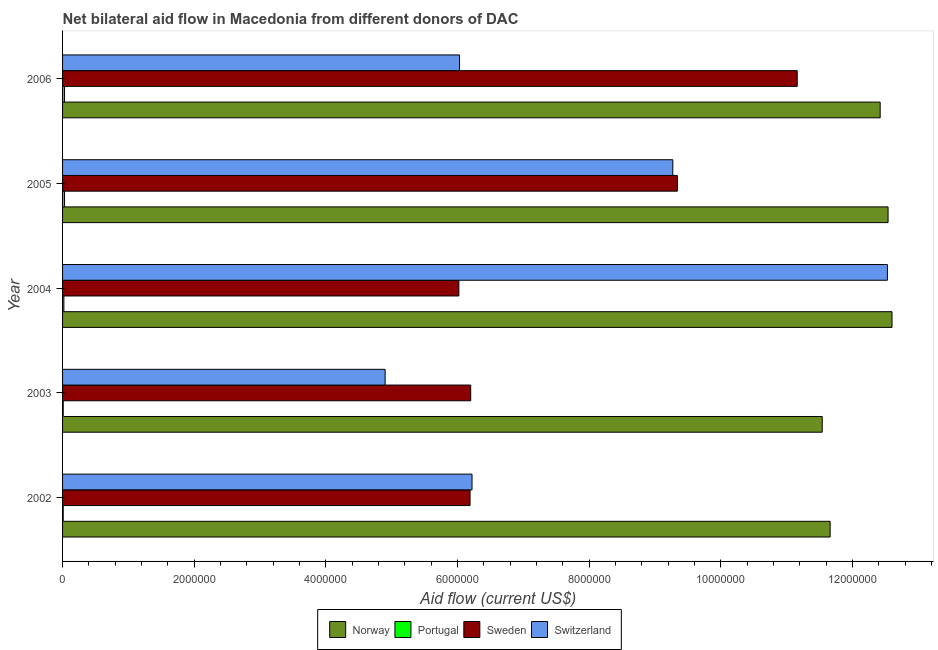How many different coloured bars are there?
Your answer should be compact. 4. Are the number of bars per tick equal to the number of legend labels?
Provide a short and direct response. Yes. Are the number of bars on each tick of the Y-axis equal?
Your answer should be very brief. Yes. How many bars are there on the 5th tick from the top?
Your answer should be very brief. 4. What is the label of the 3rd group of bars from the top?
Offer a very short reply. 2004. In how many cases, is the number of bars for a given year not equal to the number of legend labels?
Provide a short and direct response. 0. What is the amount of aid given by portugal in 2004?
Your answer should be compact. 2.00e+04. Across all years, what is the maximum amount of aid given by portugal?
Provide a short and direct response. 3.00e+04. Across all years, what is the minimum amount of aid given by sweden?
Your response must be concise. 6.02e+06. In which year was the amount of aid given by switzerland maximum?
Your answer should be compact. 2004. In which year was the amount of aid given by norway minimum?
Your answer should be very brief. 2003. What is the total amount of aid given by norway in the graph?
Your answer should be very brief. 6.08e+07. What is the difference between the amount of aid given by switzerland in 2003 and that in 2004?
Keep it short and to the point. -7.63e+06. What is the difference between the amount of aid given by norway in 2002 and the amount of aid given by portugal in 2005?
Offer a very short reply. 1.16e+07. What is the average amount of aid given by portugal per year?
Give a very brief answer. 2.00e+04. In the year 2006, what is the difference between the amount of aid given by portugal and amount of aid given by sweden?
Make the answer very short. -1.11e+07. What is the ratio of the amount of aid given by norway in 2002 to that in 2003?
Provide a succinct answer. 1.01. Is the amount of aid given by norway in 2004 less than that in 2006?
Offer a very short reply. No. Is the difference between the amount of aid given by switzerland in 2004 and 2006 greater than the difference between the amount of aid given by norway in 2004 and 2006?
Your answer should be compact. Yes. What is the difference between the highest and the lowest amount of aid given by switzerland?
Provide a short and direct response. 7.63e+06. In how many years, is the amount of aid given by sweden greater than the average amount of aid given by sweden taken over all years?
Your answer should be compact. 2. Is the sum of the amount of aid given by switzerland in 2002 and 2003 greater than the maximum amount of aid given by norway across all years?
Your answer should be compact. No. Is it the case that in every year, the sum of the amount of aid given by portugal and amount of aid given by sweden is greater than the sum of amount of aid given by switzerland and amount of aid given by norway?
Your answer should be compact. No. What does the 4th bar from the bottom in 2006 represents?
Your answer should be very brief. Switzerland. Is it the case that in every year, the sum of the amount of aid given by norway and amount of aid given by portugal is greater than the amount of aid given by sweden?
Your answer should be very brief. Yes. How many bars are there?
Provide a short and direct response. 20. Are all the bars in the graph horizontal?
Your answer should be very brief. Yes. Does the graph contain grids?
Ensure brevity in your answer.  No. How many legend labels are there?
Your answer should be compact. 4. How are the legend labels stacked?
Your answer should be very brief. Horizontal. What is the title of the graph?
Offer a terse response. Net bilateral aid flow in Macedonia from different donors of DAC. Does "Debt policy" appear as one of the legend labels in the graph?
Offer a very short reply. No. What is the label or title of the X-axis?
Your answer should be compact. Aid flow (current US$). What is the label or title of the Y-axis?
Offer a very short reply. Year. What is the Aid flow (current US$) of Norway in 2002?
Offer a very short reply. 1.17e+07. What is the Aid flow (current US$) in Portugal in 2002?
Your response must be concise. 10000. What is the Aid flow (current US$) in Sweden in 2002?
Your answer should be compact. 6.19e+06. What is the Aid flow (current US$) of Switzerland in 2002?
Offer a terse response. 6.22e+06. What is the Aid flow (current US$) of Norway in 2003?
Provide a short and direct response. 1.15e+07. What is the Aid flow (current US$) in Sweden in 2003?
Give a very brief answer. 6.20e+06. What is the Aid flow (current US$) in Switzerland in 2003?
Your response must be concise. 4.90e+06. What is the Aid flow (current US$) in Norway in 2004?
Your answer should be compact. 1.26e+07. What is the Aid flow (current US$) in Sweden in 2004?
Make the answer very short. 6.02e+06. What is the Aid flow (current US$) of Switzerland in 2004?
Your response must be concise. 1.25e+07. What is the Aid flow (current US$) in Norway in 2005?
Offer a very short reply. 1.25e+07. What is the Aid flow (current US$) in Portugal in 2005?
Your response must be concise. 3.00e+04. What is the Aid flow (current US$) of Sweden in 2005?
Your answer should be very brief. 9.34e+06. What is the Aid flow (current US$) in Switzerland in 2005?
Make the answer very short. 9.27e+06. What is the Aid flow (current US$) in Norway in 2006?
Offer a terse response. 1.24e+07. What is the Aid flow (current US$) in Sweden in 2006?
Provide a succinct answer. 1.12e+07. What is the Aid flow (current US$) of Switzerland in 2006?
Keep it short and to the point. 6.03e+06. Across all years, what is the maximum Aid flow (current US$) of Norway?
Make the answer very short. 1.26e+07. Across all years, what is the maximum Aid flow (current US$) of Portugal?
Keep it short and to the point. 3.00e+04. Across all years, what is the maximum Aid flow (current US$) in Sweden?
Your answer should be compact. 1.12e+07. Across all years, what is the maximum Aid flow (current US$) in Switzerland?
Give a very brief answer. 1.25e+07. Across all years, what is the minimum Aid flow (current US$) of Norway?
Your response must be concise. 1.15e+07. Across all years, what is the minimum Aid flow (current US$) in Portugal?
Keep it short and to the point. 10000. Across all years, what is the minimum Aid flow (current US$) of Sweden?
Your answer should be compact. 6.02e+06. Across all years, what is the minimum Aid flow (current US$) of Switzerland?
Provide a short and direct response. 4.90e+06. What is the total Aid flow (current US$) in Norway in the graph?
Make the answer very short. 6.08e+07. What is the total Aid flow (current US$) in Portugal in the graph?
Keep it short and to the point. 1.00e+05. What is the total Aid flow (current US$) of Sweden in the graph?
Offer a very short reply. 3.89e+07. What is the total Aid flow (current US$) in Switzerland in the graph?
Your answer should be very brief. 3.90e+07. What is the difference between the Aid flow (current US$) in Norway in 2002 and that in 2003?
Your answer should be very brief. 1.20e+05. What is the difference between the Aid flow (current US$) of Portugal in 2002 and that in 2003?
Offer a very short reply. 0. What is the difference between the Aid flow (current US$) in Sweden in 2002 and that in 2003?
Your answer should be very brief. -10000. What is the difference between the Aid flow (current US$) of Switzerland in 2002 and that in 2003?
Give a very brief answer. 1.32e+06. What is the difference between the Aid flow (current US$) of Norway in 2002 and that in 2004?
Provide a short and direct response. -9.40e+05. What is the difference between the Aid flow (current US$) in Sweden in 2002 and that in 2004?
Ensure brevity in your answer.  1.70e+05. What is the difference between the Aid flow (current US$) in Switzerland in 2002 and that in 2004?
Your response must be concise. -6.31e+06. What is the difference between the Aid flow (current US$) of Norway in 2002 and that in 2005?
Provide a short and direct response. -8.80e+05. What is the difference between the Aid flow (current US$) in Portugal in 2002 and that in 2005?
Provide a succinct answer. -2.00e+04. What is the difference between the Aid flow (current US$) in Sweden in 2002 and that in 2005?
Make the answer very short. -3.15e+06. What is the difference between the Aid flow (current US$) of Switzerland in 2002 and that in 2005?
Make the answer very short. -3.05e+06. What is the difference between the Aid flow (current US$) in Norway in 2002 and that in 2006?
Ensure brevity in your answer.  -7.60e+05. What is the difference between the Aid flow (current US$) of Sweden in 2002 and that in 2006?
Give a very brief answer. -4.97e+06. What is the difference between the Aid flow (current US$) of Norway in 2003 and that in 2004?
Offer a very short reply. -1.06e+06. What is the difference between the Aid flow (current US$) in Portugal in 2003 and that in 2004?
Provide a succinct answer. -10000. What is the difference between the Aid flow (current US$) in Sweden in 2003 and that in 2004?
Offer a terse response. 1.80e+05. What is the difference between the Aid flow (current US$) of Switzerland in 2003 and that in 2004?
Keep it short and to the point. -7.63e+06. What is the difference between the Aid flow (current US$) of Sweden in 2003 and that in 2005?
Give a very brief answer. -3.14e+06. What is the difference between the Aid flow (current US$) in Switzerland in 2003 and that in 2005?
Provide a short and direct response. -4.37e+06. What is the difference between the Aid flow (current US$) in Norway in 2003 and that in 2006?
Your answer should be very brief. -8.80e+05. What is the difference between the Aid flow (current US$) of Portugal in 2003 and that in 2006?
Give a very brief answer. -2.00e+04. What is the difference between the Aid flow (current US$) of Sweden in 2003 and that in 2006?
Offer a terse response. -4.96e+06. What is the difference between the Aid flow (current US$) of Switzerland in 2003 and that in 2006?
Your answer should be very brief. -1.13e+06. What is the difference between the Aid flow (current US$) in Norway in 2004 and that in 2005?
Keep it short and to the point. 6.00e+04. What is the difference between the Aid flow (current US$) of Portugal in 2004 and that in 2005?
Make the answer very short. -10000. What is the difference between the Aid flow (current US$) of Sweden in 2004 and that in 2005?
Ensure brevity in your answer.  -3.32e+06. What is the difference between the Aid flow (current US$) of Switzerland in 2004 and that in 2005?
Your answer should be very brief. 3.26e+06. What is the difference between the Aid flow (current US$) of Norway in 2004 and that in 2006?
Keep it short and to the point. 1.80e+05. What is the difference between the Aid flow (current US$) in Sweden in 2004 and that in 2006?
Keep it short and to the point. -5.14e+06. What is the difference between the Aid flow (current US$) in Switzerland in 2004 and that in 2006?
Provide a succinct answer. 6.50e+06. What is the difference between the Aid flow (current US$) in Norway in 2005 and that in 2006?
Your answer should be very brief. 1.20e+05. What is the difference between the Aid flow (current US$) of Sweden in 2005 and that in 2006?
Your answer should be compact. -1.82e+06. What is the difference between the Aid flow (current US$) in Switzerland in 2005 and that in 2006?
Ensure brevity in your answer.  3.24e+06. What is the difference between the Aid flow (current US$) in Norway in 2002 and the Aid flow (current US$) in Portugal in 2003?
Give a very brief answer. 1.16e+07. What is the difference between the Aid flow (current US$) in Norway in 2002 and the Aid flow (current US$) in Sweden in 2003?
Provide a succinct answer. 5.46e+06. What is the difference between the Aid flow (current US$) in Norway in 2002 and the Aid flow (current US$) in Switzerland in 2003?
Make the answer very short. 6.76e+06. What is the difference between the Aid flow (current US$) in Portugal in 2002 and the Aid flow (current US$) in Sweden in 2003?
Your answer should be compact. -6.19e+06. What is the difference between the Aid flow (current US$) in Portugal in 2002 and the Aid flow (current US$) in Switzerland in 2003?
Your answer should be very brief. -4.89e+06. What is the difference between the Aid flow (current US$) in Sweden in 2002 and the Aid flow (current US$) in Switzerland in 2003?
Your response must be concise. 1.29e+06. What is the difference between the Aid flow (current US$) of Norway in 2002 and the Aid flow (current US$) of Portugal in 2004?
Offer a very short reply. 1.16e+07. What is the difference between the Aid flow (current US$) in Norway in 2002 and the Aid flow (current US$) in Sweden in 2004?
Provide a short and direct response. 5.64e+06. What is the difference between the Aid flow (current US$) of Norway in 2002 and the Aid flow (current US$) of Switzerland in 2004?
Keep it short and to the point. -8.70e+05. What is the difference between the Aid flow (current US$) of Portugal in 2002 and the Aid flow (current US$) of Sweden in 2004?
Keep it short and to the point. -6.01e+06. What is the difference between the Aid flow (current US$) of Portugal in 2002 and the Aid flow (current US$) of Switzerland in 2004?
Your response must be concise. -1.25e+07. What is the difference between the Aid flow (current US$) of Sweden in 2002 and the Aid flow (current US$) of Switzerland in 2004?
Offer a very short reply. -6.34e+06. What is the difference between the Aid flow (current US$) of Norway in 2002 and the Aid flow (current US$) of Portugal in 2005?
Provide a short and direct response. 1.16e+07. What is the difference between the Aid flow (current US$) in Norway in 2002 and the Aid flow (current US$) in Sweden in 2005?
Make the answer very short. 2.32e+06. What is the difference between the Aid flow (current US$) in Norway in 2002 and the Aid flow (current US$) in Switzerland in 2005?
Your answer should be very brief. 2.39e+06. What is the difference between the Aid flow (current US$) of Portugal in 2002 and the Aid flow (current US$) of Sweden in 2005?
Give a very brief answer. -9.33e+06. What is the difference between the Aid flow (current US$) in Portugal in 2002 and the Aid flow (current US$) in Switzerland in 2005?
Give a very brief answer. -9.26e+06. What is the difference between the Aid flow (current US$) of Sweden in 2002 and the Aid flow (current US$) of Switzerland in 2005?
Offer a terse response. -3.08e+06. What is the difference between the Aid flow (current US$) in Norway in 2002 and the Aid flow (current US$) in Portugal in 2006?
Keep it short and to the point. 1.16e+07. What is the difference between the Aid flow (current US$) in Norway in 2002 and the Aid flow (current US$) in Switzerland in 2006?
Your answer should be compact. 5.63e+06. What is the difference between the Aid flow (current US$) in Portugal in 2002 and the Aid flow (current US$) in Sweden in 2006?
Offer a terse response. -1.12e+07. What is the difference between the Aid flow (current US$) in Portugal in 2002 and the Aid flow (current US$) in Switzerland in 2006?
Make the answer very short. -6.02e+06. What is the difference between the Aid flow (current US$) in Norway in 2003 and the Aid flow (current US$) in Portugal in 2004?
Provide a short and direct response. 1.15e+07. What is the difference between the Aid flow (current US$) of Norway in 2003 and the Aid flow (current US$) of Sweden in 2004?
Give a very brief answer. 5.52e+06. What is the difference between the Aid flow (current US$) in Norway in 2003 and the Aid flow (current US$) in Switzerland in 2004?
Provide a succinct answer. -9.90e+05. What is the difference between the Aid flow (current US$) in Portugal in 2003 and the Aid flow (current US$) in Sweden in 2004?
Offer a very short reply. -6.01e+06. What is the difference between the Aid flow (current US$) in Portugal in 2003 and the Aid flow (current US$) in Switzerland in 2004?
Ensure brevity in your answer.  -1.25e+07. What is the difference between the Aid flow (current US$) of Sweden in 2003 and the Aid flow (current US$) of Switzerland in 2004?
Give a very brief answer. -6.33e+06. What is the difference between the Aid flow (current US$) in Norway in 2003 and the Aid flow (current US$) in Portugal in 2005?
Ensure brevity in your answer.  1.15e+07. What is the difference between the Aid flow (current US$) in Norway in 2003 and the Aid flow (current US$) in Sweden in 2005?
Keep it short and to the point. 2.20e+06. What is the difference between the Aid flow (current US$) in Norway in 2003 and the Aid flow (current US$) in Switzerland in 2005?
Ensure brevity in your answer.  2.27e+06. What is the difference between the Aid flow (current US$) in Portugal in 2003 and the Aid flow (current US$) in Sweden in 2005?
Make the answer very short. -9.33e+06. What is the difference between the Aid flow (current US$) in Portugal in 2003 and the Aid flow (current US$) in Switzerland in 2005?
Offer a very short reply. -9.26e+06. What is the difference between the Aid flow (current US$) in Sweden in 2003 and the Aid flow (current US$) in Switzerland in 2005?
Offer a very short reply. -3.07e+06. What is the difference between the Aid flow (current US$) in Norway in 2003 and the Aid flow (current US$) in Portugal in 2006?
Provide a short and direct response. 1.15e+07. What is the difference between the Aid flow (current US$) in Norway in 2003 and the Aid flow (current US$) in Sweden in 2006?
Offer a very short reply. 3.80e+05. What is the difference between the Aid flow (current US$) in Norway in 2003 and the Aid flow (current US$) in Switzerland in 2006?
Make the answer very short. 5.51e+06. What is the difference between the Aid flow (current US$) in Portugal in 2003 and the Aid flow (current US$) in Sweden in 2006?
Provide a succinct answer. -1.12e+07. What is the difference between the Aid flow (current US$) of Portugal in 2003 and the Aid flow (current US$) of Switzerland in 2006?
Offer a terse response. -6.02e+06. What is the difference between the Aid flow (current US$) in Sweden in 2003 and the Aid flow (current US$) in Switzerland in 2006?
Ensure brevity in your answer.  1.70e+05. What is the difference between the Aid flow (current US$) of Norway in 2004 and the Aid flow (current US$) of Portugal in 2005?
Provide a succinct answer. 1.26e+07. What is the difference between the Aid flow (current US$) in Norway in 2004 and the Aid flow (current US$) in Sweden in 2005?
Keep it short and to the point. 3.26e+06. What is the difference between the Aid flow (current US$) of Norway in 2004 and the Aid flow (current US$) of Switzerland in 2005?
Your response must be concise. 3.33e+06. What is the difference between the Aid flow (current US$) of Portugal in 2004 and the Aid flow (current US$) of Sweden in 2005?
Your response must be concise. -9.32e+06. What is the difference between the Aid flow (current US$) in Portugal in 2004 and the Aid flow (current US$) in Switzerland in 2005?
Ensure brevity in your answer.  -9.25e+06. What is the difference between the Aid flow (current US$) in Sweden in 2004 and the Aid flow (current US$) in Switzerland in 2005?
Your answer should be compact. -3.25e+06. What is the difference between the Aid flow (current US$) of Norway in 2004 and the Aid flow (current US$) of Portugal in 2006?
Your answer should be very brief. 1.26e+07. What is the difference between the Aid flow (current US$) of Norway in 2004 and the Aid flow (current US$) of Sweden in 2006?
Your answer should be compact. 1.44e+06. What is the difference between the Aid flow (current US$) in Norway in 2004 and the Aid flow (current US$) in Switzerland in 2006?
Your answer should be very brief. 6.57e+06. What is the difference between the Aid flow (current US$) of Portugal in 2004 and the Aid flow (current US$) of Sweden in 2006?
Your response must be concise. -1.11e+07. What is the difference between the Aid flow (current US$) in Portugal in 2004 and the Aid flow (current US$) in Switzerland in 2006?
Keep it short and to the point. -6.01e+06. What is the difference between the Aid flow (current US$) in Norway in 2005 and the Aid flow (current US$) in Portugal in 2006?
Provide a succinct answer. 1.25e+07. What is the difference between the Aid flow (current US$) in Norway in 2005 and the Aid flow (current US$) in Sweden in 2006?
Give a very brief answer. 1.38e+06. What is the difference between the Aid flow (current US$) in Norway in 2005 and the Aid flow (current US$) in Switzerland in 2006?
Your response must be concise. 6.51e+06. What is the difference between the Aid flow (current US$) of Portugal in 2005 and the Aid flow (current US$) of Sweden in 2006?
Ensure brevity in your answer.  -1.11e+07. What is the difference between the Aid flow (current US$) of Portugal in 2005 and the Aid flow (current US$) of Switzerland in 2006?
Offer a very short reply. -6.00e+06. What is the difference between the Aid flow (current US$) of Sweden in 2005 and the Aid flow (current US$) of Switzerland in 2006?
Keep it short and to the point. 3.31e+06. What is the average Aid flow (current US$) of Norway per year?
Make the answer very short. 1.22e+07. What is the average Aid flow (current US$) of Portugal per year?
Your answer should be very brief. 2.00e+04. What is the average Aid flow (current US$) of Sweden per year?
Provide a succinct answer. 7.78e+06. What is the average Aid flow (current US$) of Switzerland per year?
Provide a short and direct response. 7.79e+06. In the year 2002, what is the difference between the Aid flow (current US$) of Norway and Aid flow (current US$) of Portugal?
Provide a short and direct response. 1.16e+07. In the year 2002, what is the difference between the Aid flow (current US$) in Norway and Aid flow (current US$) in Sweden?
Give a very brief answer. 5.47e+06. In the year 2002, what is the difference between the Aid flow (current US$) in Norway and Aid flow (current US$) in Switzerland?
Your response must be concise. 5.44e+06. In the year 2002, what is the difference between the Aid flow (current US$) of Portugal and Aid flow (current US$) of Sweden?
Your answer should be very brief. -6.18e+06. In the year 2002, what is the difference between the Aid flow (current US$) of Portugal and Aid flow (current US$) of Switzerland?
Offer a very short reply. -6.21e+06. In the year 2002, what is the difference between the Aid flow (current US$) of Sweden and Aid flow (current US$) of Switzerland?
Your answer should be very brief. -3.00e+04. In the year 2003, what is the difference between the Aid flow (current US$) in Norway and Aid flow (current US$) in Portugal?
Provide a succinct answer. 1.15e+07. In the year 2003, what is the difference between the Aid flow (current US$) of Norway and Aid flow (current US$) of Sweden?
Provide a succinct answer. 5.34e+06. In the year 2003, what is the difference between the Aid flow (current US$) of Norway and Aid flow (current US$) of Switzerland?
Your response must be concise. 6.64e+06. In the year 2003, what is the difference between the Aid flow (current US$) in Portugal and Aid flow (current US$) in Sweden?
Provide a short and direct response. -6.19e+06. In the year 2003, what is the difference between the Aid flow (current US$) in Portugal and Aid flow (current US$) in Switzerland?
Make the answer very short. -4.89e+06. In the year 2003, what is the difference between the Aid flow (current US$) in Sweden and Aid flow (current US$) in Switzerland?
Make the answer very short. 1.30e+06. In the year 2004, what is the difference between the Aid flow (current US$) of Norway and Aid flow (current US$) of Portugal?
Offer a terse response. 1.26e+07. In the year 2004, what is the difference between the Aid flow (current US$) in Norway and Aid flow (current US$) in Sweden?
Give a very brief answer. 6.58e+06. In the year 2004, what is the difference between the Aid flow (current US$) in Norway and Aid flow (current US$) in Switzerland?
Give a very brief answer. 7.00e+04. In the year 2004, what is the difference between the Aid flow (current US$) in Portugal and Aid flow (current US$) in Sweden?
Ensure brevity in your answer.  -6.00e+06. In the year 2004, what is the difference between the Aid flow (current US$) of Portugal and Aid flow (current US$) of Switzerland?
Make the answer very short. -1.25e+07. In the year 2004, what is the difference between the Aid flow (current US$) in Sweden and Aid flow (current US$) in Switzerland?
Offer a terse response. -6.51e+06. In the year 2005, what is the difference between the Aid flow (current US$) in Norway and Aid flow (current US$) in Portugal?
Make the answer very short. 1.25e+07. In the year 2005, what is the difference between the Aid flow (current US$) in Norway and Aid flow (current US$) in Sweden?
Your answer should be very brief. 3.20e+06. In the year 2005, what is the difference between the Aid flow (current US$) of Norway and Aid flow (current US$) of Switzerland?
Your response must be concise. 3.27e+06. In the year 2005, what is the difference between the Aid flow (current US$) of Portugal and Aid flow (current US$) of Sweden?
Provide a succinct answer. -9.31e+06. In the year 2005, what is the difference between the Aid flow (current US$) of Portugal and Aid flow (current US$) of Switzerland?
Keep it short and to the point. -9.24e+06. In the year 2006, what is the difference between the Aid flow (current US$) of Norway and Aid flow (current US$) of Portugal?
Provide a succinct answer. 1.24e+07. In the year 2006, what is the difference between the Aid flow (current US$) of Norway and Aid flow (current US$) of Sweden?
Give a very brief answer. 1.26e+06. In the year 2006, what is the difference between the Aid flow (current US$) of Norway and Aid flow (current US$) of Switzerland?
Make the answer very short. 6.39e+06. In the year 2006, what is the difference between the Aid flow (current US$) of Portugal and Aid flow (current US$) of Sweden?
Your answer should be compact. -1.11e+07. In the year 2006, what is the difference between the Aid flow (current US$) in Portugal and Aid flow (current US$) in Switzerland?
Offer a very short reply. -6.00e+06. In the year 2006, what is the difference between the Aid flow (current US$) of Sweden and Aid flow (current US$) of Switzerland?
Offer a terse response. 5.13e+06. What is the ratio of the Aid flow (current US$) of Norway in 2002 to that in 2003?
Keep it short and to the point. 1.01. What is the ratio of the Aid flow (current US$) in Switzerland in 2002 to that in 2003?
Give a very brief answer. 1.27. What is the ratio of the Aid flow (current US$) of Norway in 2002 to that in 2004?
Provide a succinct answer. 0.93. What is the ratio of the Aid flow (current US$) in Sweden in 2002 to that in 2004?
Give a very brief answer. 1.03. What is the ratio of the Aid flow (current US$) of Switzerland in 2002 to that in 2004?
Your answer should be very brief. 0.5. What is the ratio of the Aid flow (current US$) of Norway in 2002 to that in 2005?
Provide a succinct answer. 0.93. What is the ratio of the Aid flow (current US$) in Sweden in 2002 to that in 2005?
Keep it short and to the point. 0.66. What is the ratio of the Aid flow (current US$) in Switzerland in 2002 to that in 2005?
Keep it short and to the point. 0.67. What is the ratio of the Aid flow (current US$) of Norway in 2002 to that in 2006?
Your response must be concise. 0.94. What is the ratio of the Aid flow (current US$) of Portugal in 2002 to that in 2006?
Your response must be concise. 0.33. What is the ratio of the Aid flow (current US$) in Sweden in 2002 to that in 2006?
Your response must be concise. 0.55. What is the ratio of the Aid flow (current US$) in Switzerland in 2002 to that in 2006?
Offer a terse response. 1.03. What is the ratio of the Aid flow (current US$) of Norway in 2003 to that in 2004?
Keep it short and to the point. 0.92. What is the ratio of the Aid flow (current US$) of Portugal in 2003 to that in 2004?
Your response must be concise. 0.5. What is the ratio of the Aid flow (current US$) of Sweden in 2003 to that in 2004?
Provide a short and direct response. 1.03. What is the ratio of the Aid flow (current US$) of Switzerland in 2003 to that in 2004?
Provide a short and direct response. 0.39. What is the ratio of the Aid flow (current US$) of Norway in 2003 to that in 2005?
Offer a terse response. 0.92. What is the ratio of the Aid flow (current US$) of Portugal in 2003 to that in 2005?
Make the answer very short. 0.33. What is the ratio of the Aid flow (current US$) in Sweden in 2003 to that in 2005?
Give a very brief answer. 0.66. What is the ratio of the Aid flow (current US$) in Switzerland in 2003 to that in 2005?
Your answer should be compact. 0.53. What is the ratio of the Aid flow (current US$) of Norway in 2003 to that in 2006?
Keep it short and to the point. 0.93. What is the ratio of the Aid flow (current US$) of Portugal in 2003 to that in 2006?
Offer a very short reply. 0.33. What is the ratio of the Aid flow (current US$) of Sweden in 2003 to that in 2006?
Provide a short and direct response. 0.56. What is the ratio of the Aid flow (current US$) in Switzerland in 2003 to that in 2006?
Keep it short and to the point. 0.81. What is the ratio of the Aid flow (current US$) of Portugal in 2004 to that in 2005?
Provide a succinct answer. 0.67. What is the ratio of the Aid flow (current US$) in Sweden in 2004 to that in 2005?
Your answer should be very brief. 0.64. What is the ratio of the Aid flow (current US$) of Switzerland in 2004 to that in 2005?
Provide a succinct answer. 1.35. What is the ratio of the Aid flow (current US$) of Norway in 2004 to that in 2006?
Ensure brevity in your answer.  1.01. What is the ratio of the Aid flow (current US$) of Sweden in 2004 to that in 2006?
Give a very brief answer. 0.54. What is the ratio of the Aid flow (current US$) in Switzerland in 2004 to that in 2006?
Give a very brief answer. 2.08. What is the ratio of the Aid flow (current US$) in Norway in 2005 to that in 2006?
Provide a short and direct response. 1.01. What is the ratio of the Aid flow (current US$) of Sweden in 2005 to that in 2006?
Your answer should be very brief. 0.84. What is the ratio of the Aid flow (current US$) in Switzerland in 2005 to that in 2006?
Your response must be concise. 1.54. What is the difference between the highest and the second highest Aid flow (current US$) in Norway?
Your answer should be very brief. 6.00e+04. What is the difference between the highest and the second highest Aid flow (current US$) of Sweden?
Provide a short and direct response. 1.82e+06. What is the difference between the highest and the second highest Aid flow (current US$) of Switzerland?
Offer a very short reply. 3.26e+06. What is the difference between the highest and the lowest Aid flow (current US$) of Norway?
Provide a succinct answer. 1.06e+06. What is the difference between the highest and the lowest Aid flow (current US$) in Portugal?
Keep it short and to the point. 2.00e+04. What is the difference between the highest and the lowest Aid flow (current US$) in Sweden?
Keep it short and to the point. 5.14e+06. What is the difference between the highest and the lowest Aid flow (current US$) in Switzerland?
Keep it short and to the point. 7.63e+06. 